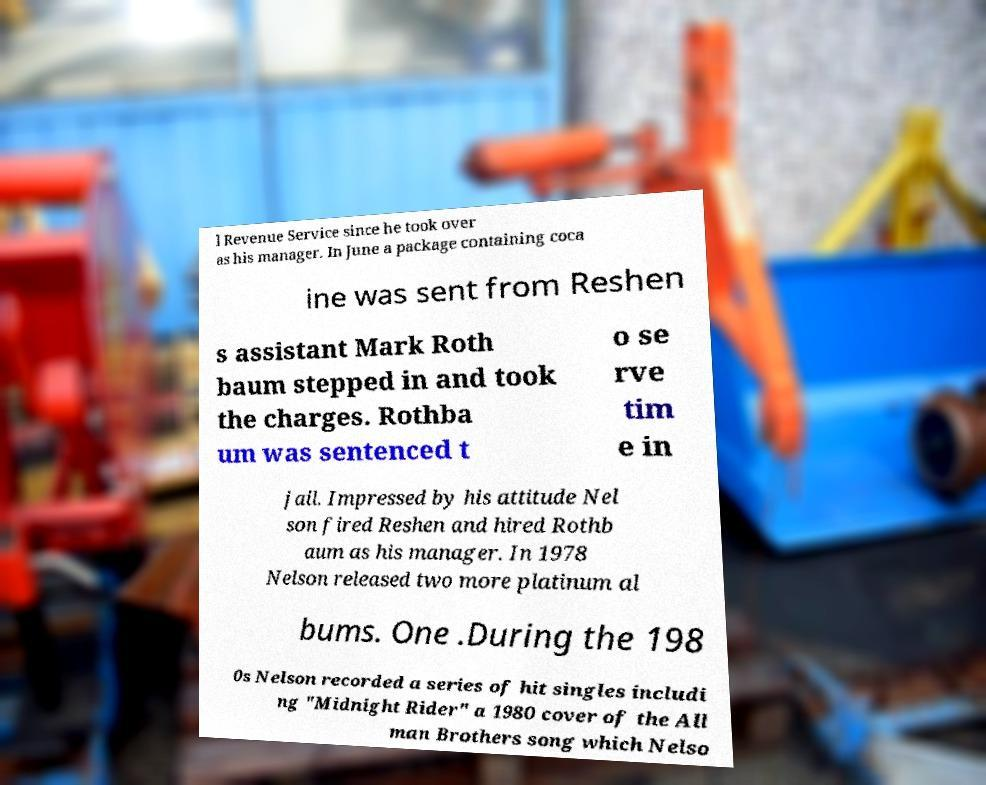Please identify and transcribe the text found in this image. l Revenue Service since he took over as his manager. In June a package containing coca ine was sent from Reshen s assistant Mark Roth baum stepped in and took the charges. Rothba um was sentenced t o se rve tim e in jail. Impressed by his attitude Nel son fired Reshen and hired Rothb aum as his manager. In 1978 Nelson released two more platinum al bums. One .During the 198 0s Nelson recorded a series of hit singles includi ng "Midnight Rider" a 1980 cover of the All man Brothers song which Nelso 